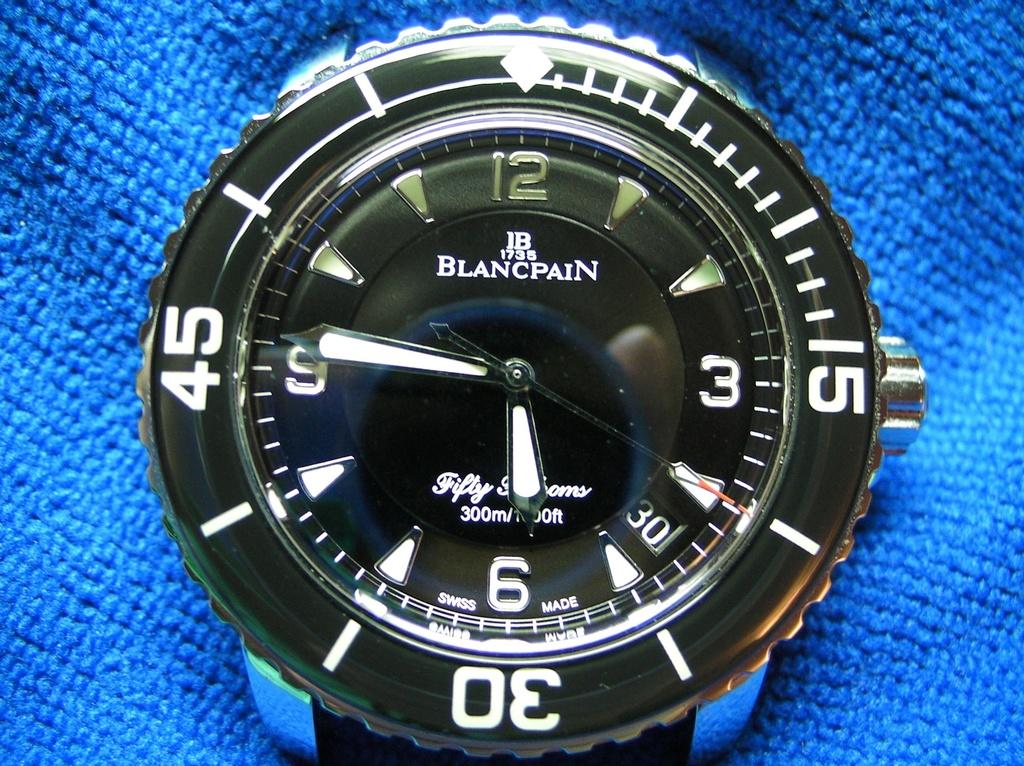<image>
Give a short and clear explanation of the subsequent image. Face of a watch that says 300m on the front. 